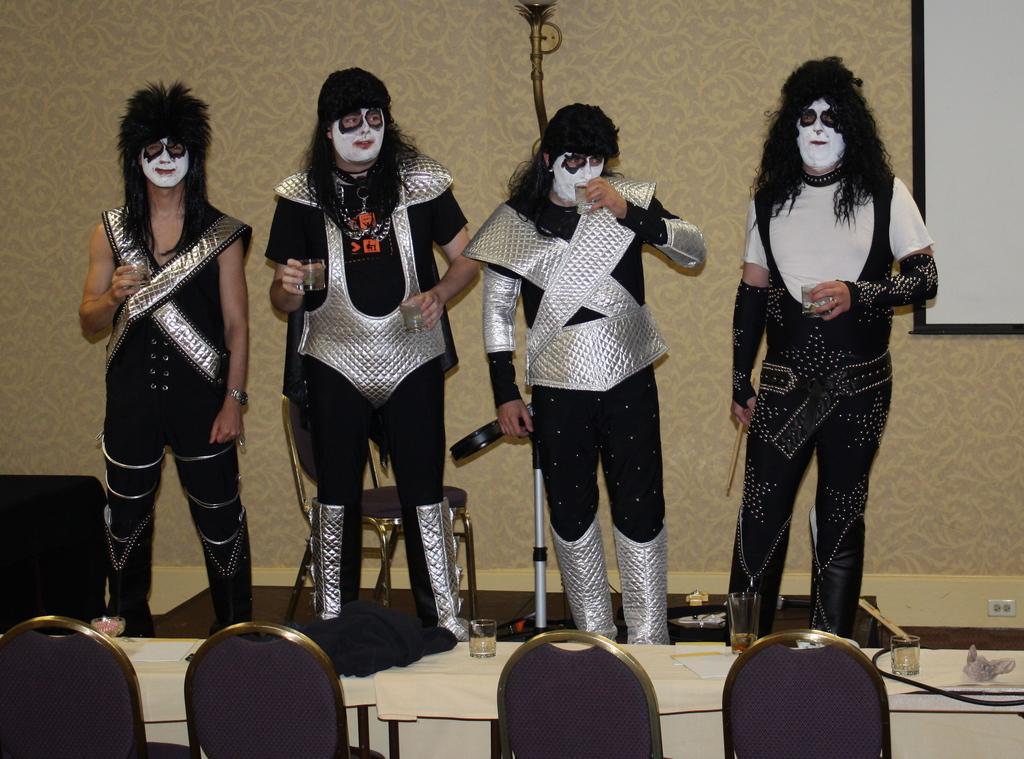How would you summarize this image in a sentence or two? In this image we can see a group of people standing on the floor wearing the costume holding some glasses. We can also see some chairs beside them and a table containing some glasses, papers, wires and a cloth on it. On the backside we can see a switchboard and a board on a wall. 